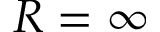Convert formula to latex. <formula><loc_0><loc_0><loc_500><loc_500>R = \infty</formula> 